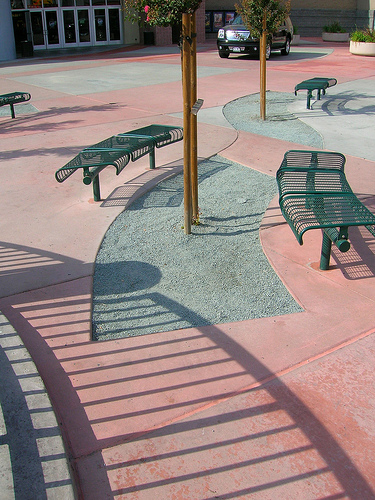<image>
Is the fence on the side path? No. The fence is not positioned on the side path. They may be near each other, but the fence is not supported by or resting on top of the side path. 